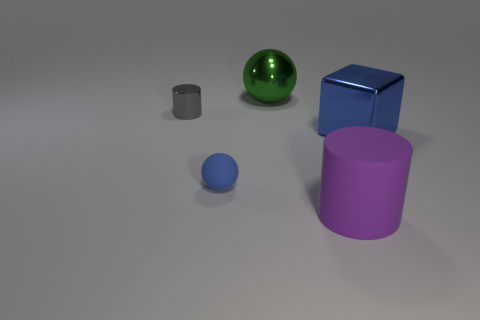Add 2 purple cylinders. How many objects exist? 7 Subtract all purple cylinders. How many cylinders are left? 1 Subtract all cylinders. How many objects are left? 3 Subtract 1 balls. How many balls are left? 1 Subtract all yellow balls. Subtract all red cylinders. How many balls are left? 2 Subtract all big gray cylinders. Subtract all blocks. How many objects are left? 4 Add 5 tiny cylinders. How many tiny cylinders are left? 6 Add 3 yellow cylinders. How many yellow cylinders exist? 3 Subtract 0 yellow blocks. How many objects are left? 5 